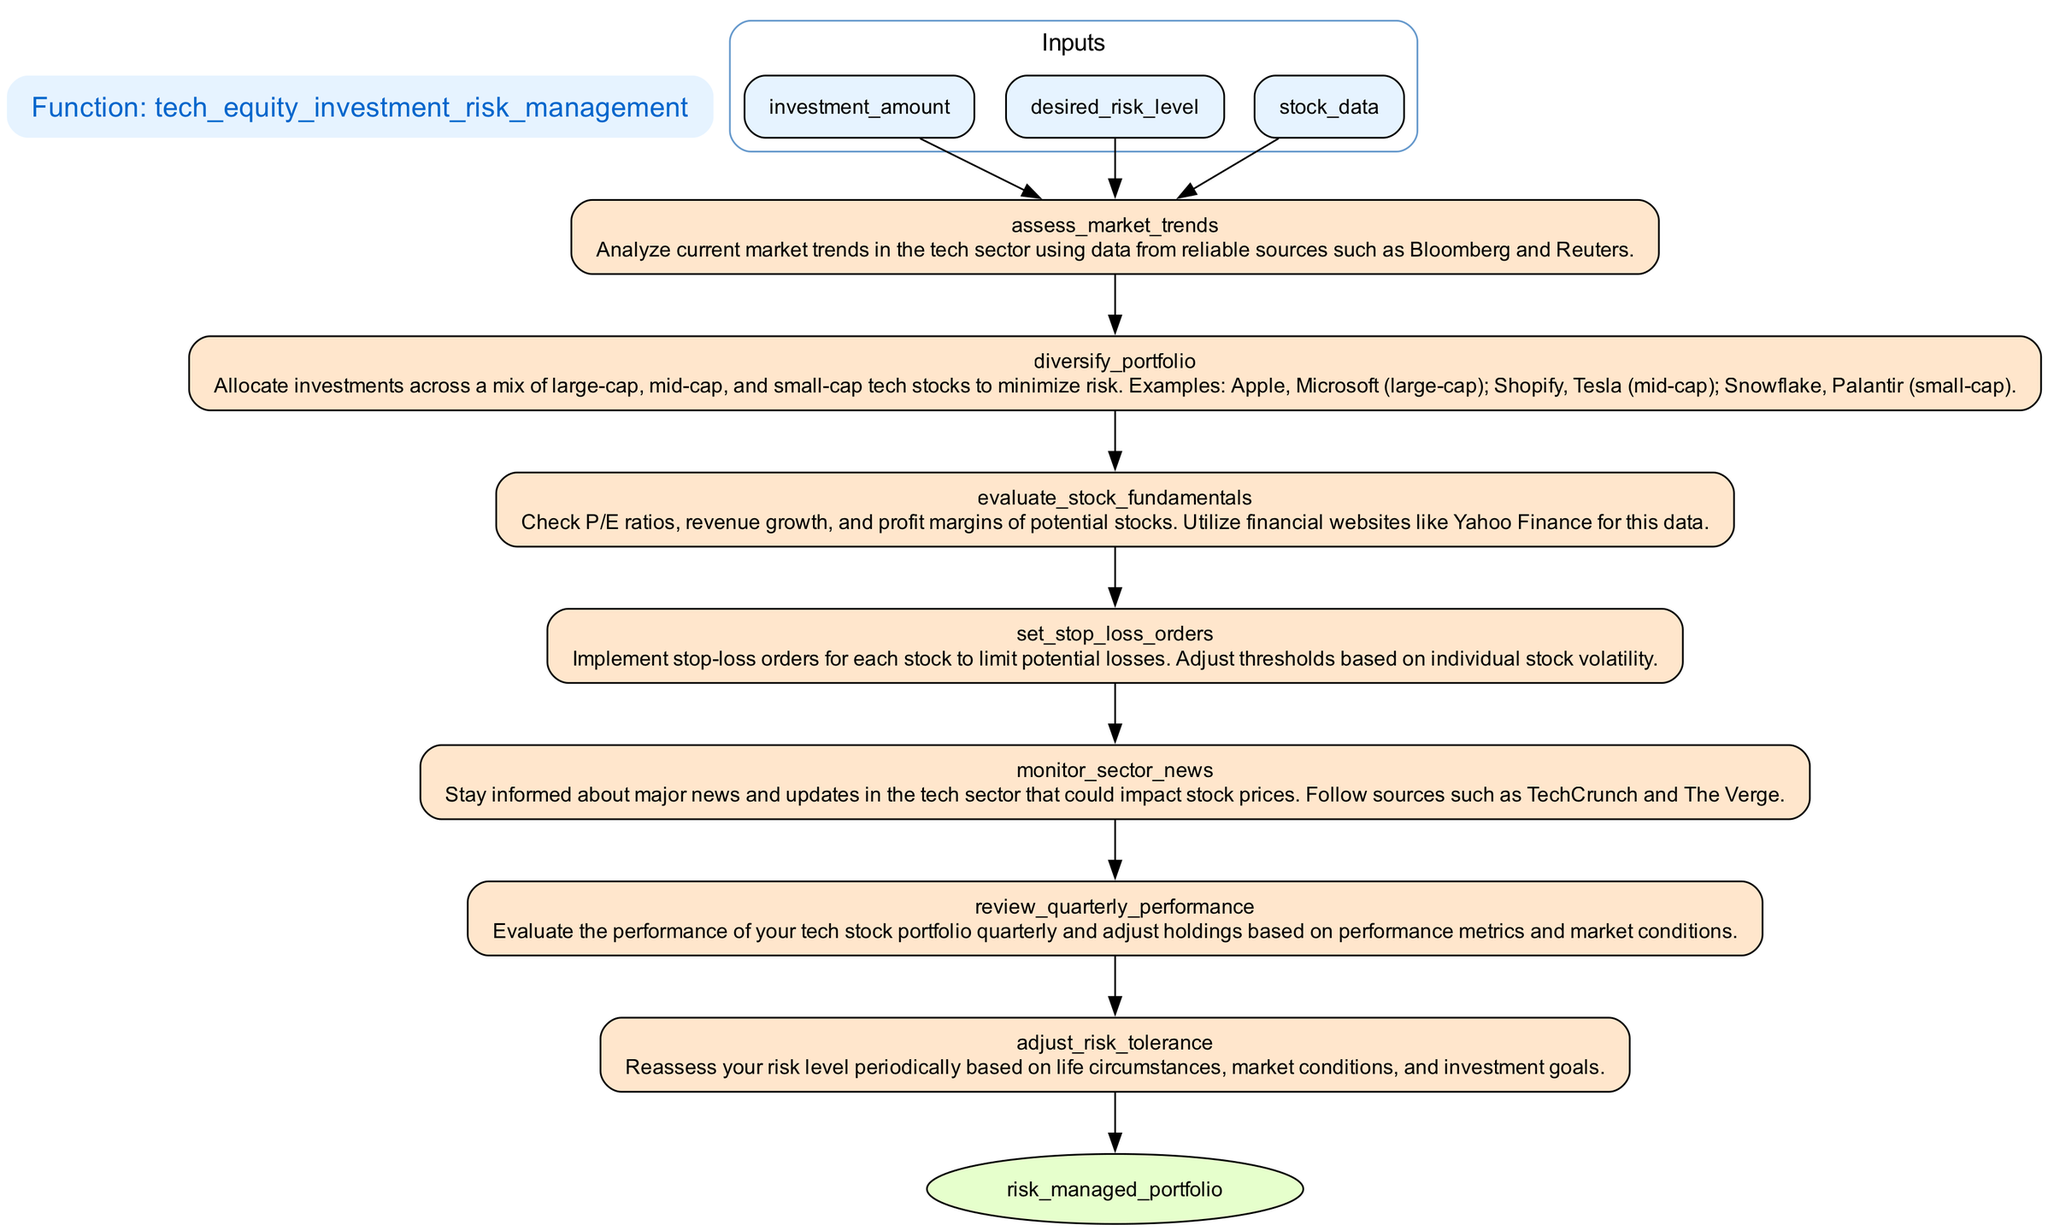What is the first step of the function? The first step in the flowchart is "assess_market_trends". It appears at the top after the inputs and outlines the initial action taken in the risk management strategy.
Answer: assess_market_trends How many inputs does the function have? The function has three inputs: "investment_amount," "desired_risk_level," and "stock_data." These are shown in the input section of the flowchart.
Answer: three What comes after "diversify_portfolio"? The step that follows "diversify_portfolio" is "evaluate_stock_fundamentals." This shows the progression in the sequence of steps in the function.
Answer: evaluate_stock_fundamentals Is "set_stop_loss_orders" a process step? Yes, "set_stop_loss_orders" is indeed a process step. It is clearly labeled among the steps outlined in the flowchart.
Answer: Yes What is the last step before the output? The last step before the output is "review_quarterly_performance." It leads directly to the output, indicating the final evaluation stage in the risk management process.
Answer: review_quarterly_performance How does the function adjust for individual stock volatility? The function sets stop-loss orders that are adjusted based on individual stock volatility. This indicates a tailored approach to risk management for each stock.
Answer: Adjust stop-loss orders Which step requires periodic reassessment? The step titled "adjust_risk_tolerance" requires periodic reassessment, highlighting the need to evaluate risk in relation to life circumstances and market conditions.
Answer: adjust_risk_tolerance Which sources are suggested for staying informed about the tech sector? The flowchart suggests following sources such as TechCrunch and The Verge for staying informed about major news in the tech sector.
Answer: TechCrunch and The Verge How does the analysis of P/E ratios influence investment decisions? The evaluation of stock fundamentals, including P/E ratios, helps assess the attractiveness of potential stocks for investment, guiding the portfolio's composition.
Answer: Assess stock fundamentals 